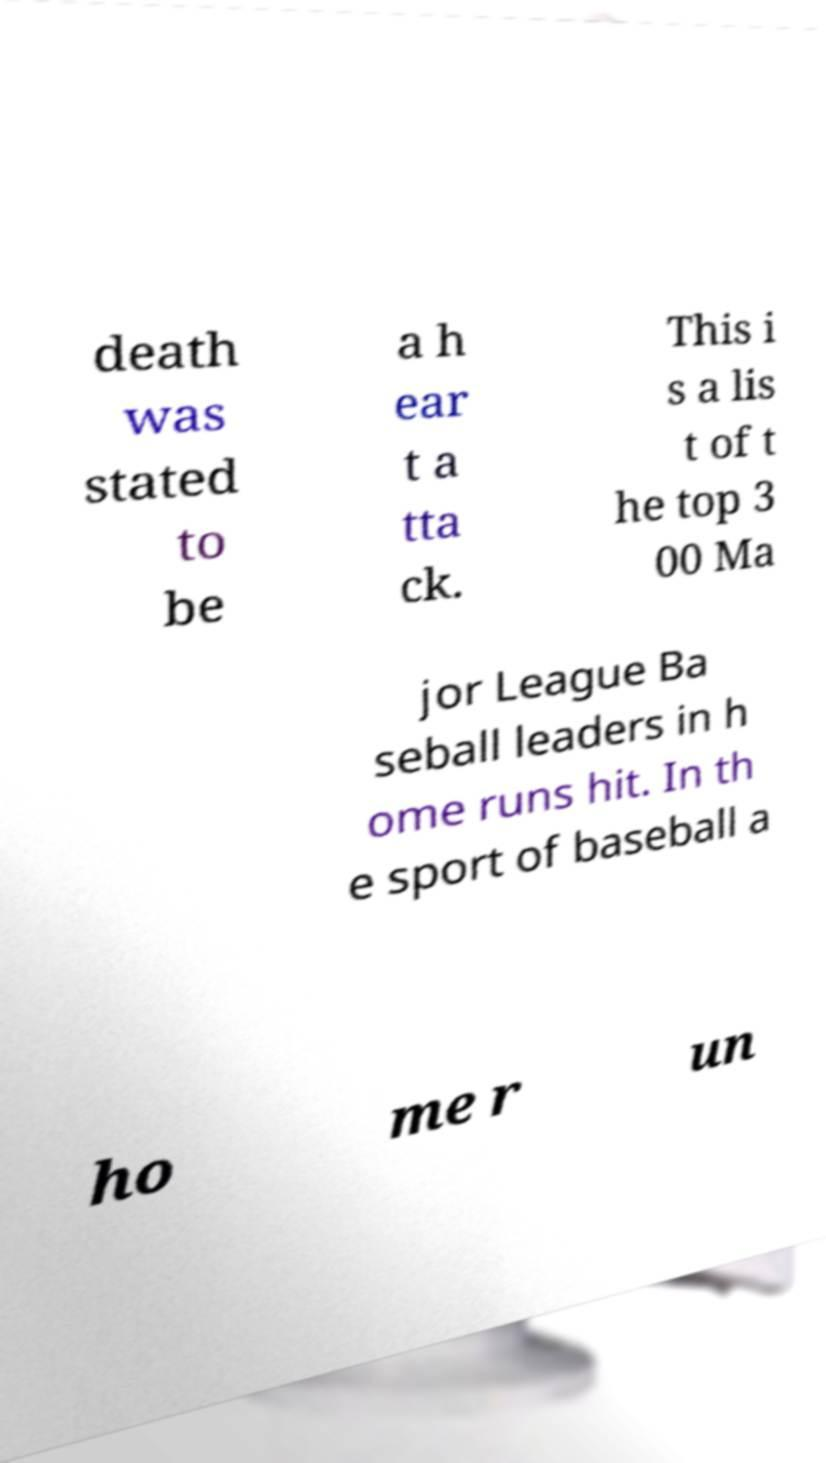There's text embedded in this image that I need extracted. Can you transcribe it verbatim? death was stated to be a h ear t a tta ck. This i s a lis t of t he top 3 00 Ma jor League Ba seball leaders in h ome runs hit. In th e sport of baseball a ho me r un 